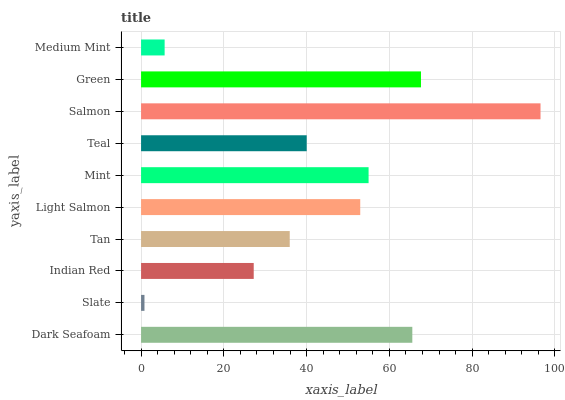Is Slate the minimum?
Answer yes or no. Yes. Is Salmon the maximum?
Answer yes or no. Yes. Is Indian Red the minimum?
Answer yes or no. No. Is Indian Red the maximum?
Answer yes or no. No. Is Indian Red greater than Slate?
Answer yes or no. Yes. Is Slate less than Indian Red?
Answer yes or no. Yes. Is Slate greater than Indian Red?
Answer yes or no. No. Is Indian Red less than Slate?
Answer yes or no. No. Is Light Salmon the high median?
Answer yes or no. Yes. Is Teal the low median?
Answer yes or no. Yes. Is Salmon the high median?
Answer yes or no. No. Is Indian Red the low median?
Answer yes or no. No. 